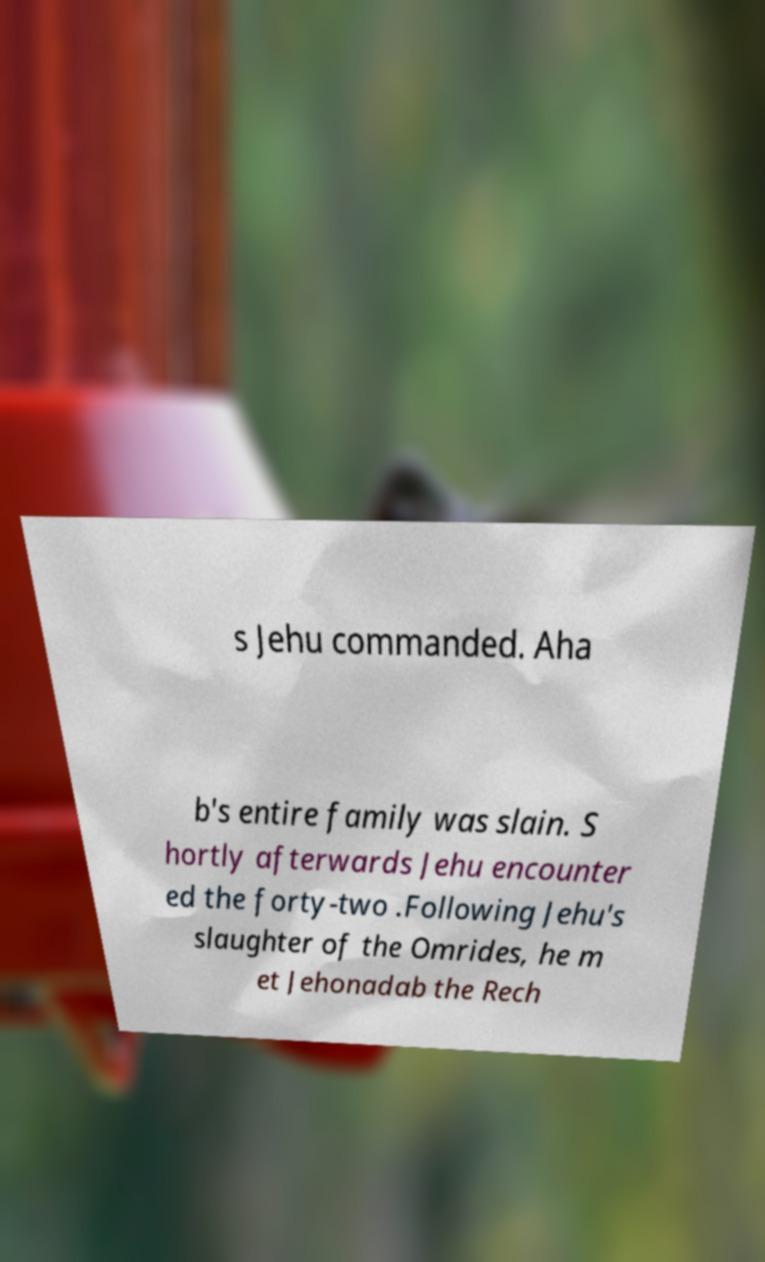I need the written content from this picture converted into text. Can you do that? s Jehu commanded. Aha b's entire family was slain. S hortly afterwards Jehu encounter ed the forty-two .Following Jehu's slaughter of the Omrides, he m et Jehonadab the Rech 